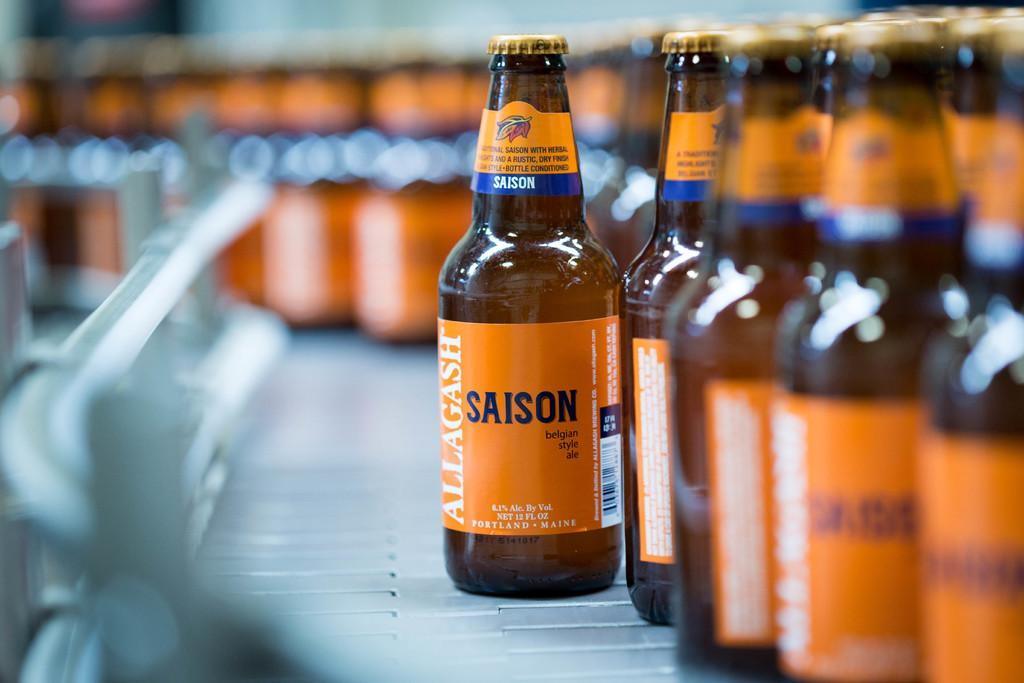Provide a one-sentence caption for the provided image. Many bottles of Allagash Saison sit on an assembly line. 